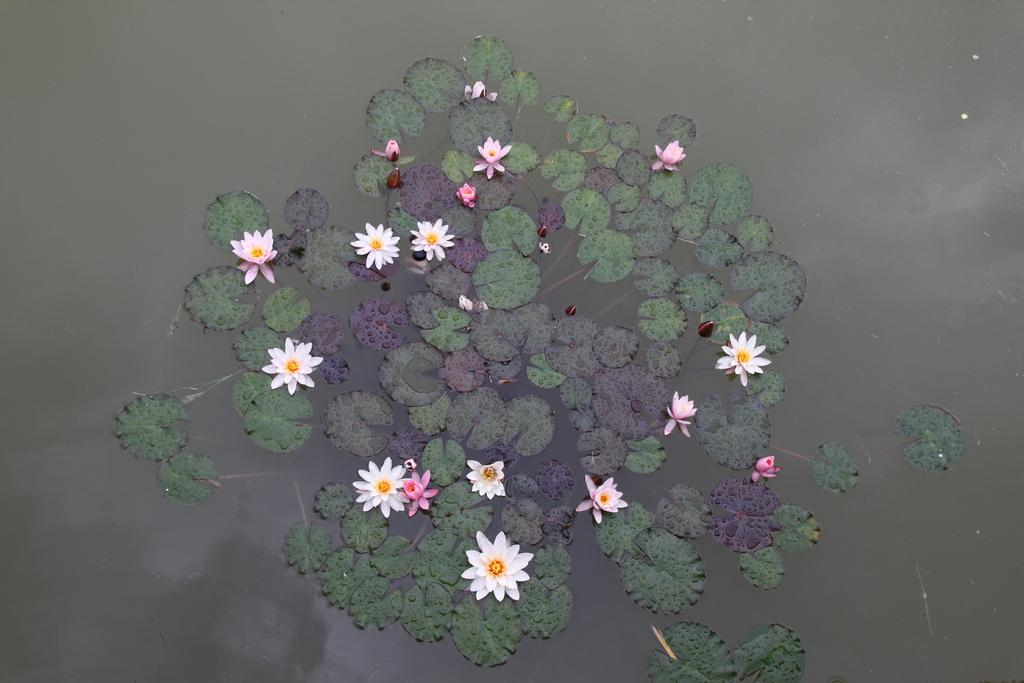What type of body of water is depicted in the image? The image is of a pond. What type of flowers can be seen in the pond? There are lotus flowers in the image. What else can be seen in the pond besides the flowers? There are leaves in the image. What type of soup is being served in the image? There is no soup present in the image; it is a picture of a pond with lotus flowers and leaves. 